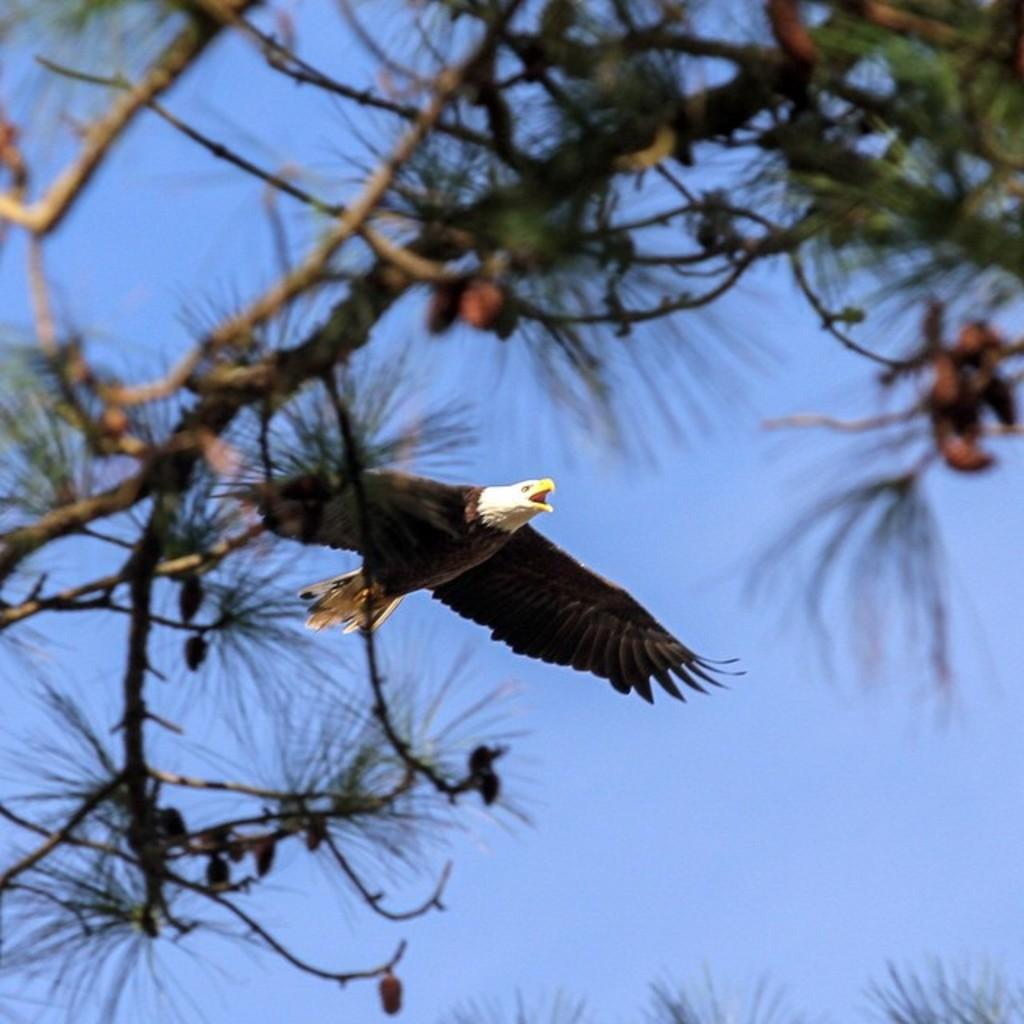What is one of the natural elements present in the image? There is a tree in the picture. What is happening in the sky in the image? There is an eagle flying in the sky. What type of waste can be seen on the ground in the image? There is no waste present in the image; it features a tree and an eagle flying in the sky. What historical event is depicted in the image? The image does not depict any historical event; it features a tree and an eagle flying in the sky. 